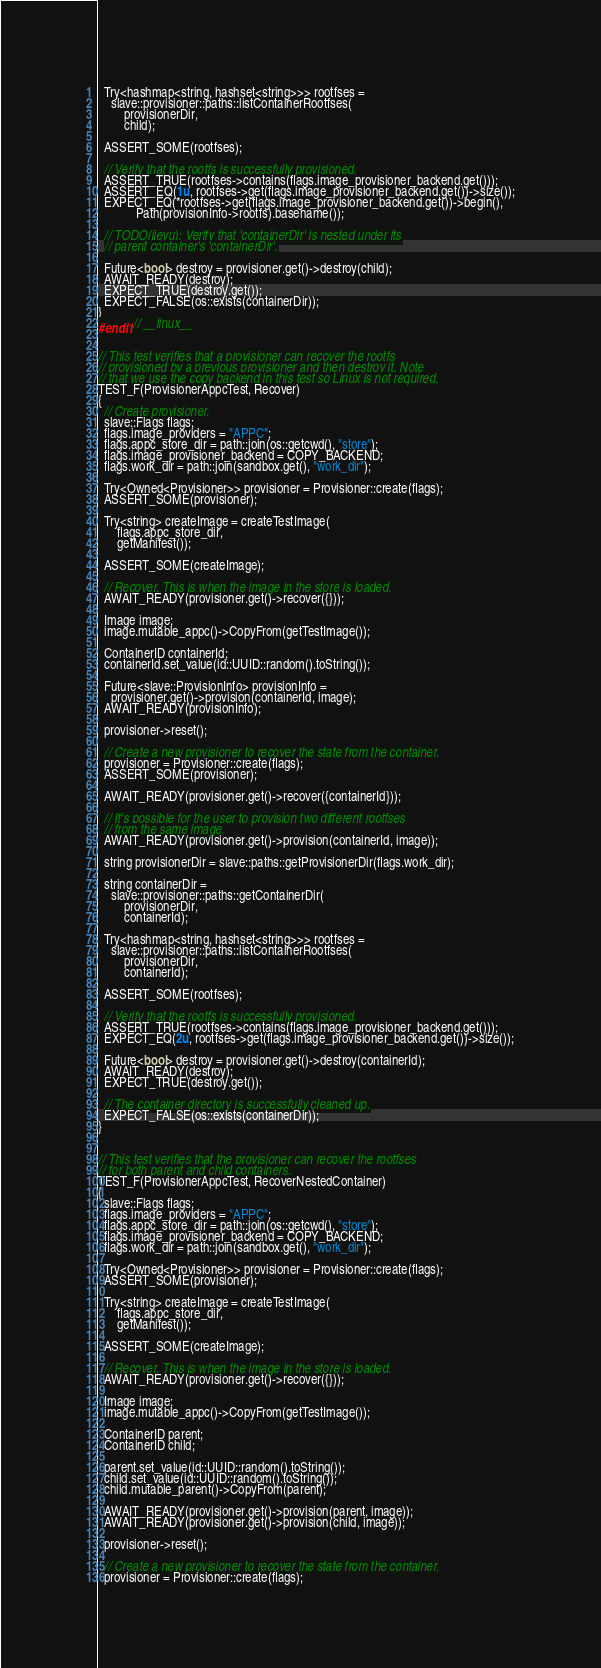Convert code to text. <code><loc_0><loc_0><loc_500><loc_500><_C++_>  Try<hashmap<string, hashset<string>>> rootfses =
    slave::provisioner::paths::listContainerRootfses(
        provisionerDir,
        child);

  ASSERT_SOME(rootfses);

  // Verify that the rootfs is successfully provisioned.
  ASSERT_TRUE(rootfses->contains(flags.image_provisioner_backend.get()));
  ASSERT_EQ(1u, rootfses->get(flags.image_provisioner_backend.get())->size());
  EXPECT_EQ(*rootfses->get(flags.image_provisioner_backend.get())->begin(),
            Path(provisionInfo->rootfs).basename());

  // TODO(jieyu): Verify that 'containerDir' is nested under its
  // parent container's 'containerDir'.

  Future<bool> destroy = provisioner.get()->destroy(child);
  AWAIT_READY(destroy);
  EXPECT_TRUE(destroy.get());
  EXPECT_FALSE(os::exists(containerDir));
}
#endif // __linux__


// This test verifies that a provisioner can recover the rootfs
// provisioned by a previous provisioner and then destroy it. Note
// that we use the copy backend in this test so Linux is not required.
TEST_F(ProvisionerAppcTest, Recover)
{
  // Create provisioner.
  slave::Flags flags;
  flags.image_providers = "APPC";
  flags.appc_store_dir = path::join(os::getcwd(), "store");
  flags.image_provisioner_backend = COPY_BACKEND;
  flags.work_dir = path::join(sandbox.get(), "work_dir");

  Try<Owned<Provisioner>> provisioner = Provisioner::create(flags);
  ASSERT_SOME(provisioner);

  Try<string> createImage = createTestImage(
      flags.appc_store_dir,
      getManifest());

  ASSERT_SOME(createImage);

  // Recover. This is when the image in the store is loaded.
  AWAIT_READY(provisioner.get()->recover({}));

  Image image;
  image.mutable_appc()->CopyFrom(getTestImage());

  ContainerID containerId;
  containerId.set_value(id::UUID::random().toString());

  Future<slave::ProvisionInfo> provisionInfo =
    provisioner.get()->provision(containerId, image);
  AWAIT_READY(provisionInfo);

  provisioner->reset();

  // Create a new provisioner to recover the state from the container.
  provisioner = Provisioner::create(flags);
  ASSERT_SOME(provisioner);

  AWAIT_READY(provisioner.get()->recover({containerId}));

  // It's possible for the user to provision two different rootfses
  // from the same image.
  AWAIT_READY(provisioner.get()->provision(containerId, image));

  string provisionerDir = slave::paths::getProvisionerDir(flags.work_dir);

  string containerDir =
    slave::provisioner::paths::getContainerDir(
        provisionerDir,
        containerId);

  Try<hashmap<string, hashset<string>>> rootfses =
    slave::provisioner::paths::listContainerRootfses(
        provisionerDir,
        containerId);

  ASSERT_SOME(rootfses);

  // Verify that the rootfs is successfully provisioned.
  ASSERT_TRUE(rootfses->contains(flags.image_provisioner_backend.get()));
  EXPECT_EQ(2u, rootfses->get(flags.image_provisioner_backend.get())->size());

  Future<bool> destroy = provisioner.get()->destroy(containerId);
  AWAIT_READY(destroy);
  EXPECT_TRUE(destroy.get());

  // The container directory is successfully cleaned up.
  EXPECT_FALSE(os::exists(containerDir));
}


// This test verifies that the provisioner can recover the rootfses
// for both parent and child containers.
TEST_F(ProvisionerAppcTest, RecoverNestedContainer)
{
  slave::Flags flags;
  flags.image_providers = "APPC";
  flags.appc_store_dir = path::join(os::getcwd(), "store");
  flags.image_provisioner_backend = COPY_BACKEND;
  flags.work_dir = path::join(sandbox.get(), "work_dir");

  Try<Owned<Provisioner>> provisioner = Provisioner::create(flags);
  ASSERT_SOME(provisioner);

  Try<string> createImage = createTestImage(
      flags.appc_store_dir,
      getManifest());

  ASSERT_SOME(createImage);

  // Recover. This is when the image in the store is loaded.
  AWAIT_READY(provisioner.get()->recover({}));

  Image image;
  image.mutable_appc()->CopyFrom(getTestImage());

  ContainerID parent;
  ContainerID child;

  parent.set_value(id::UUID::random().toString());
  child.set_value(id::UUID::random().toString());
  child.mutable_parent()->CopyFrom(parent);

  AWAIT_READY(provisioner.get()->provision(parent, image));
  AWAIT_READY(provisioner.get()->provision(child, image));

  provisioner->reset();

  // Create a new provisioner to recover the state from the container.
  provisioner = Provisioner::create(flags);</code> 